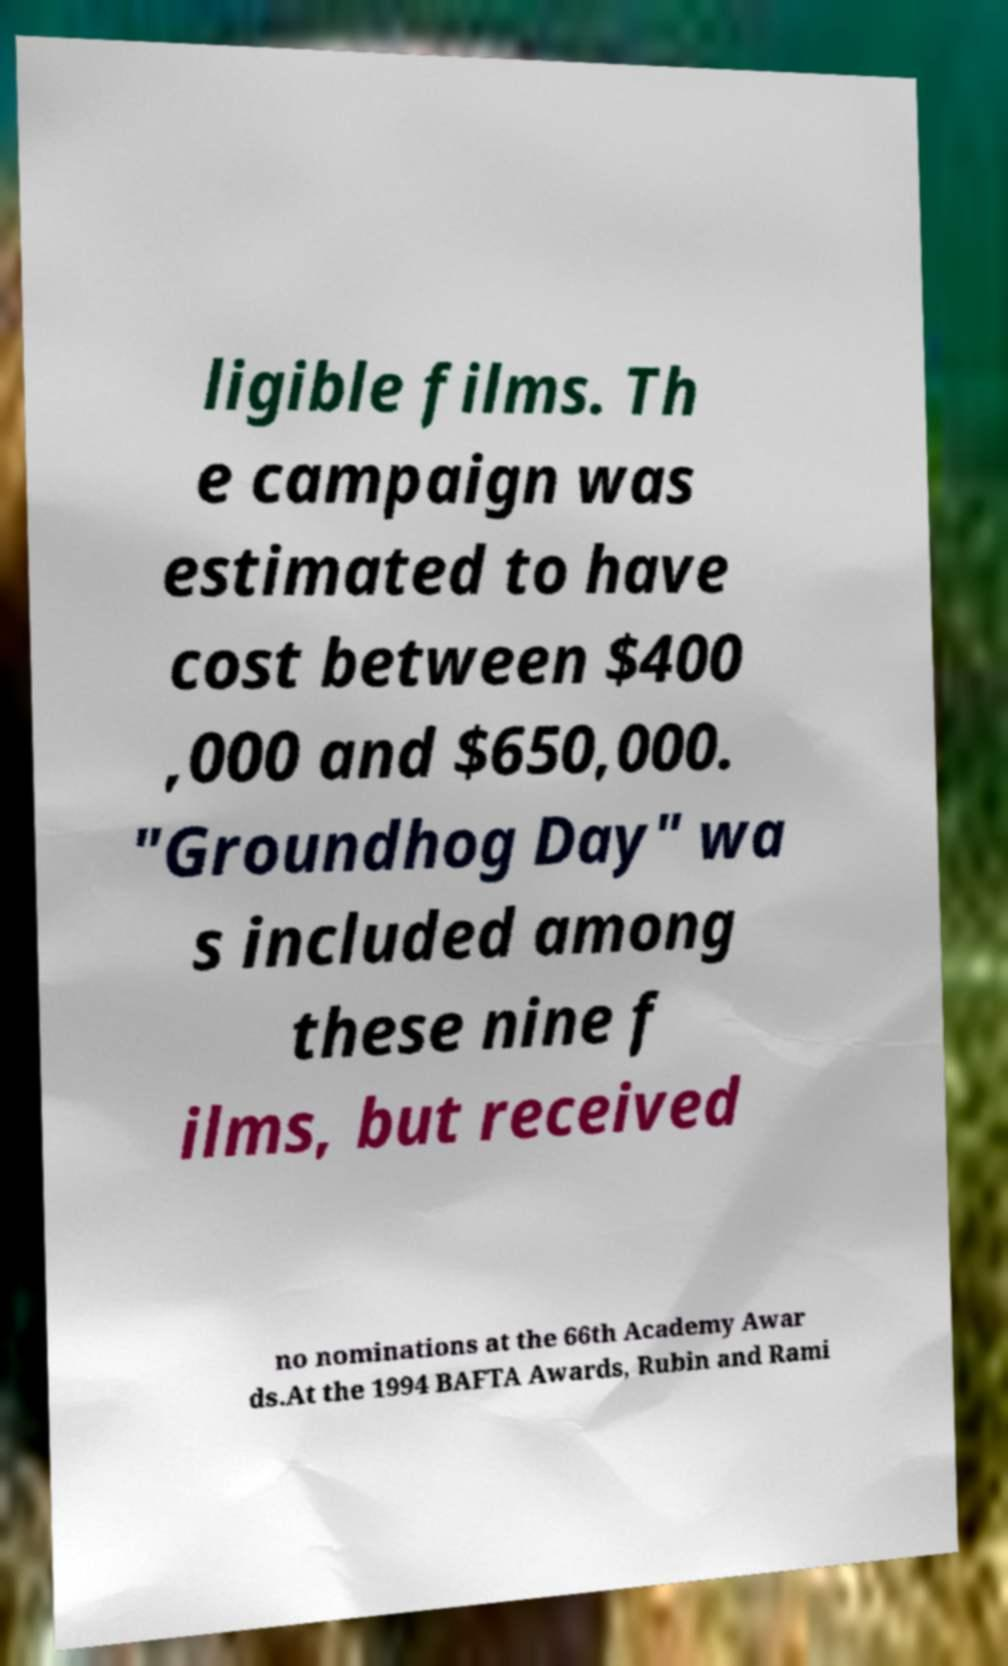Please read and relay the text visible in this image. What does it say? ligible films. Th e campaign was estimated to have cost between $400 ,000 and $650,000. "Groundhog Day" wa s included among these nine f ilms, but received no nominations at the 66th Academy Awar ds.At the 1994 BAFTA Awards, Rubin and Rami 